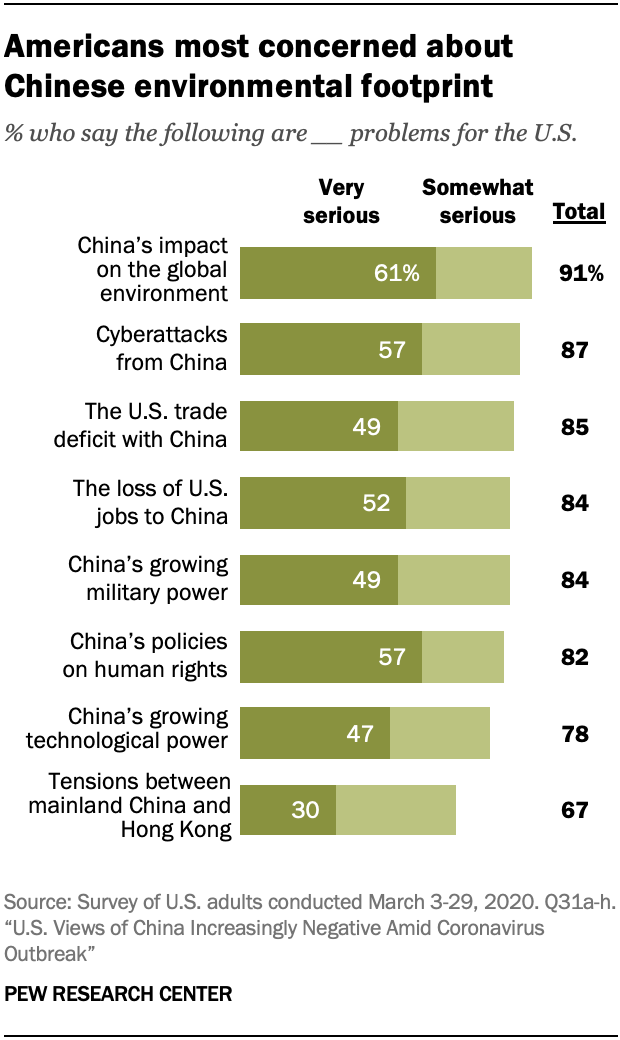Draw attention to some important aspects in this diagram. There are 4 bars in Very Serious that are below 50. A recent survey found that 57% of Americans believe that cyberattacks from China pose a very serious problem for the United States. 